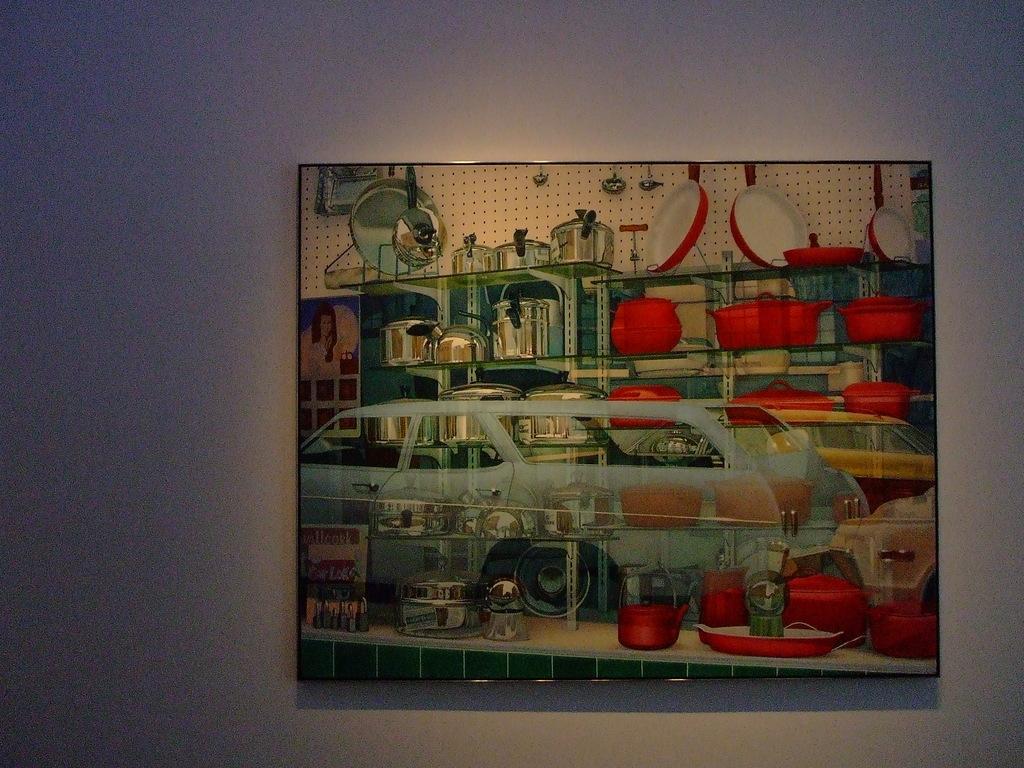Please provide a concise description of this image. In this image I can see a board which consists of some painting. This board is attached to a wall. 